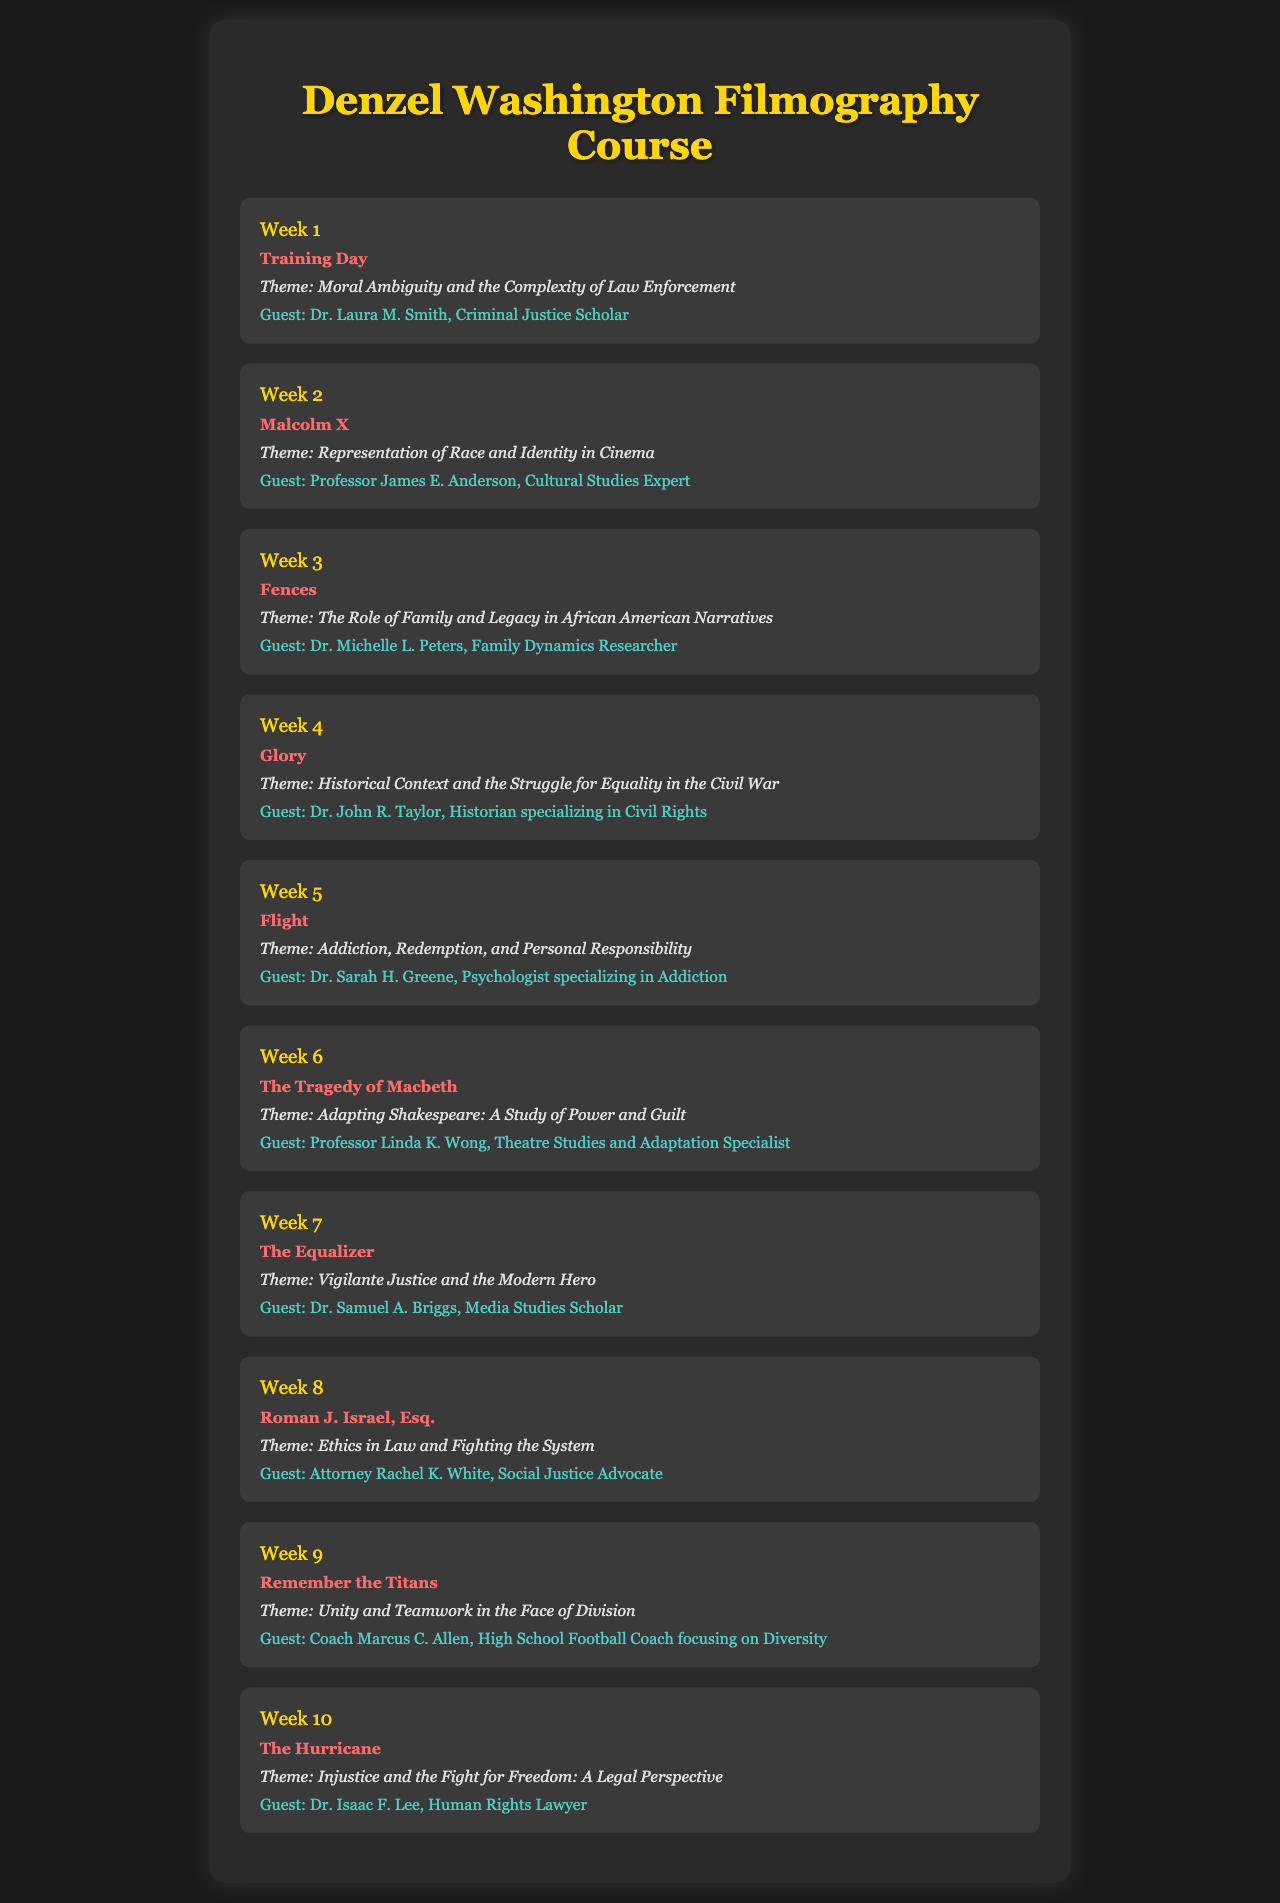What is the title of the film screened in Week 1? The title of the film screened in Week 1 is explicitly mentioned as "Training Day."
Answer: Training Day Who is the guest speaker for Week 3? The document states that the guest speaker for Week 3 is Dr. Michelle L. Peters.
Answer: Dr. Michelle L. Peters What theme is explored in the film "Malcolm X"? The theme associated with "Malcolm X" is clearly stated as "Representation of Race and Identity in Cinema."
Answer: Representation of Race and Identity in Cinema How many films are scheduled for screening in total? By counting the individual weeks listed, we note that there are 10 films scheduled for screening.
Answer: 10 Which film is associated with the theme of "Addiction, Redemption, and Personal Responsibility"? The document indicates that the film "Flight" corresponds with this theme.
Answer: Flight What week features a discussion on "Vigilante Justice and the Modern Hero"? The theme of vigilante justice is linked to "The Equalizer," which is screened in Week 7.
Answer: Week 7 What is the main theme of "Fences"? The document specifies that the theme is "The Role of Family and Legacy in African American Narratives."
Answer: The Role of Family and Legacy in African American Narratives Who specializes as a historian for Week 4? Dr. John R. Taylor is introduced as the historian specializing in Civil Rights for Week 4.
Answer: Dr. John R. Taylor Which film's theme involves "Injustice and the Fight for Freedom"? The theme of injustice and fighting for freedom is connected to "The Hurricane."
Answer: The Hurricane What is the overarching theme for Week 9's film? The film screened in Week 9 addresses the theme of "Unity and Teamwork in the Face of Division."
Answer: Unity and Teamwork in the Face of Division 